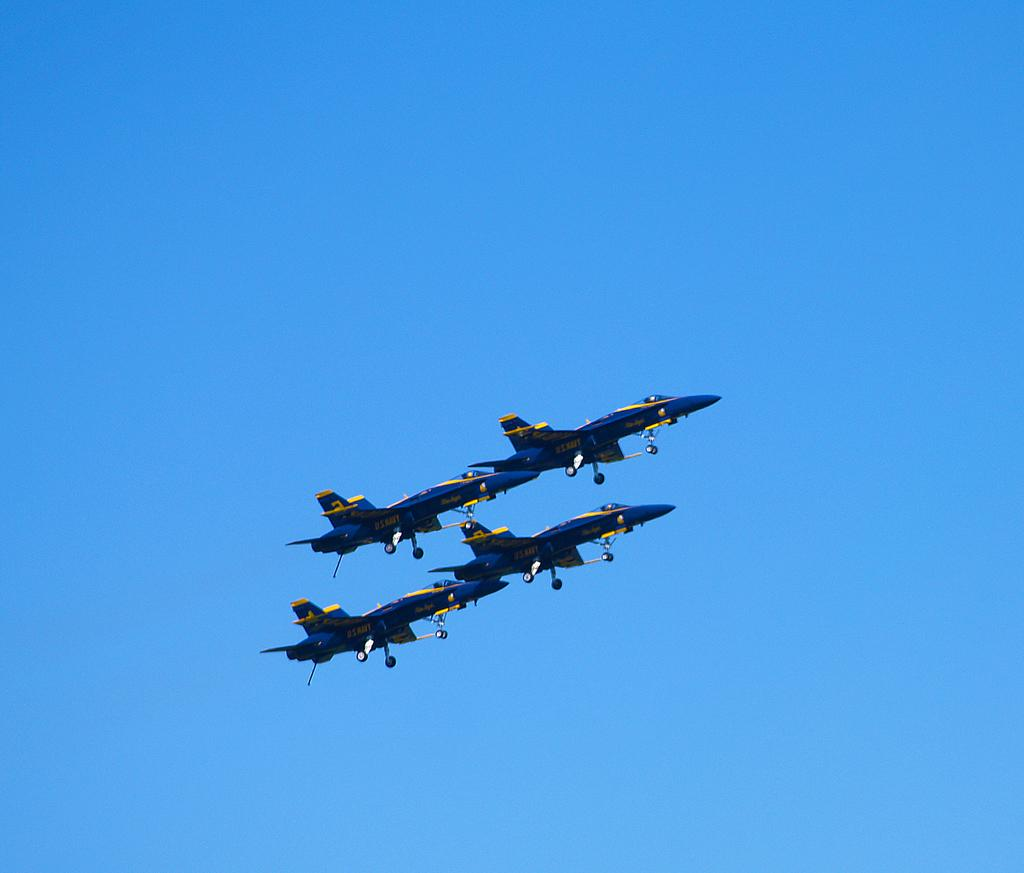What type of vehicles are in the image? There are jet planes in the image. Where are the jet planes located? The jet planes are in the air. What type of sand can be seen being used in the protest in the image? There is no protest or sand present in the image; it features jet planes in the air. What type of yam is being served at the event in the image? There is no event or yam present in the image; it features jet planes in the air. 